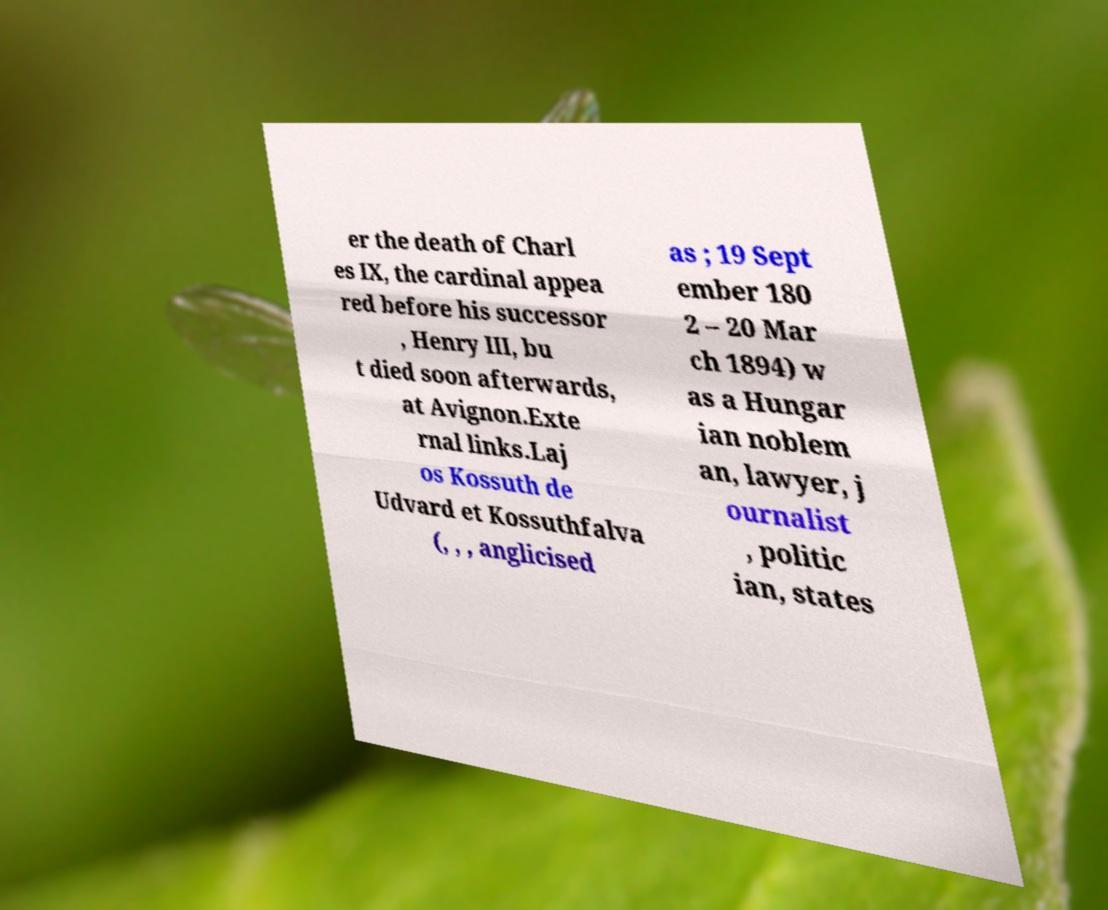There's text embedded in this image that I need extracted. Can you transcribe it verbatim? er the death of Charl es IX, the cardinal appea red before his successor , Henry III, bu t died soon afterwards, at Avignon.Exte rnal links.Laj os Kossuth de Udvard et Kossuthfalva (, , , anglicised as ; 19 Sept ember 180 2 – 20 Mar ch 1894) w as a Hungar ian noblem an, lawyer, j ournalist , politic ian, states 